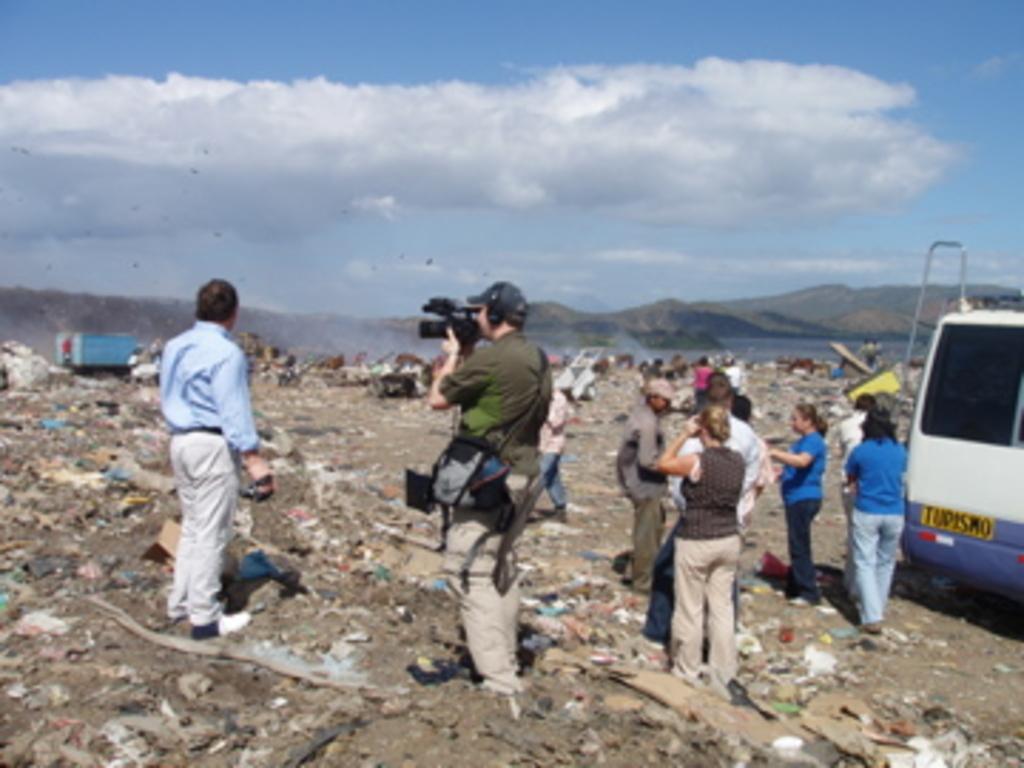In one or two sentences, can you explain what this image depicts? In this image there is a person holding the camera. Beside him there are a few other people. At the bottom of the image there is garbage. In the background of the image there are a few objects. There is water. There are mountains and sky. 